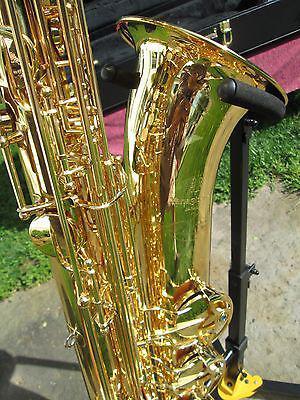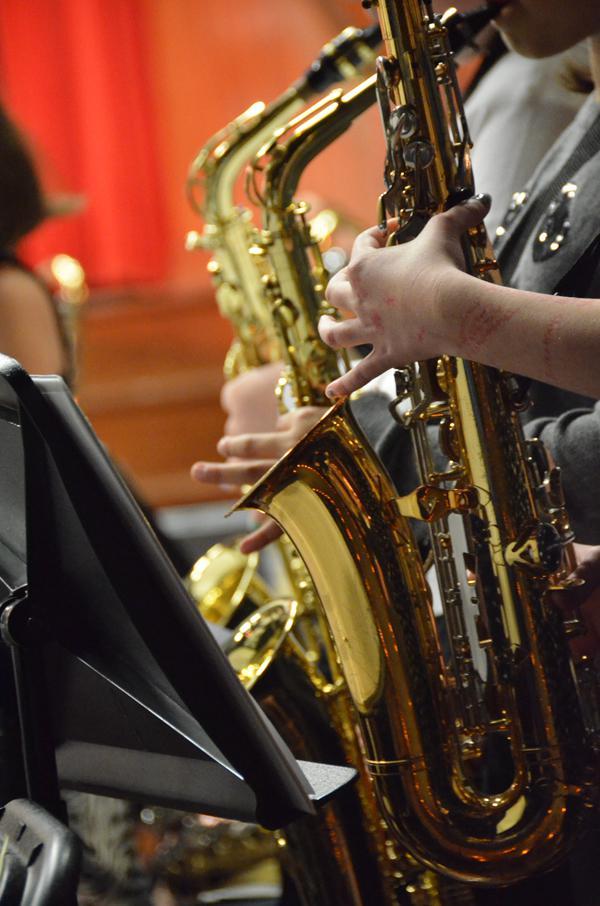The first image is the image on the left, the second image is the image on the right. Assess this claim about the two images: "One image shows a single rightward facing bell of a saxophone, and the other image shows a gold-colored leftward-facing saxophone in the foreground.". Correct or not? Answer yes or no. Yes. 